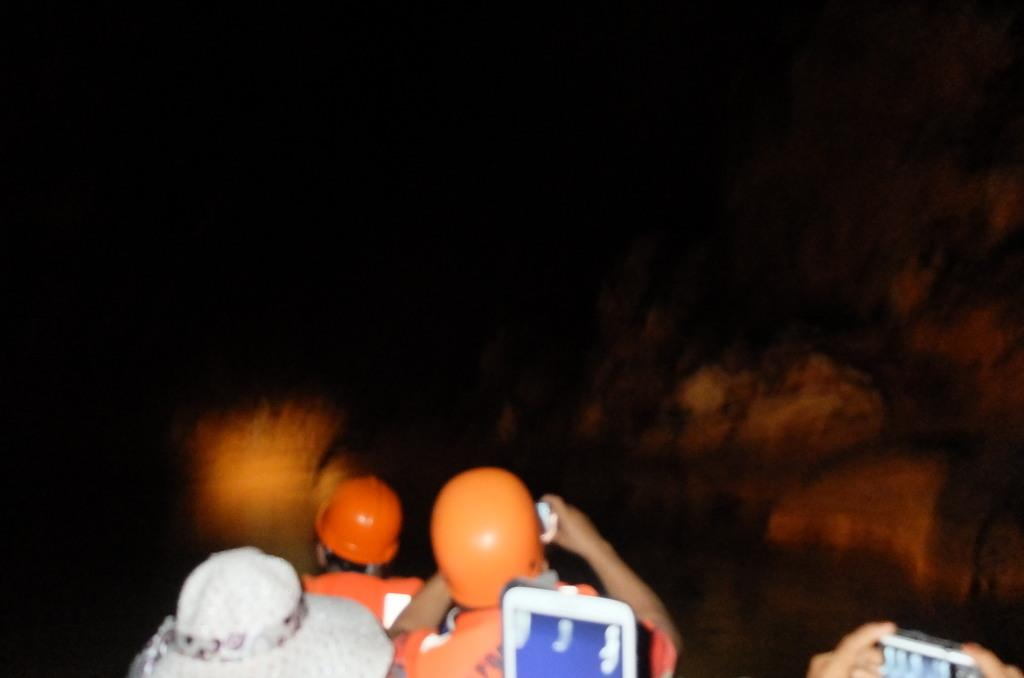What are the people in the image doing? The people in the image are sitting. What are the people holding in their hands? The people are holding objects in their hands. What can be observed about the background of the image? The background of the image is dark. Can you see any goldfish swimming in the image? There are no goldfish present in the image. What type of field can be seen in the background of the image? There is no field visible in the image, as the background is described as dark. 